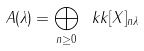Convert formula to latex. <formula><loc_0><loc_0><loc_500><loc_500>A ( \lambda ) = \bigoplus _ { n \geq 0 } \ k k [ X ] _ { n \lambda }</formula> 